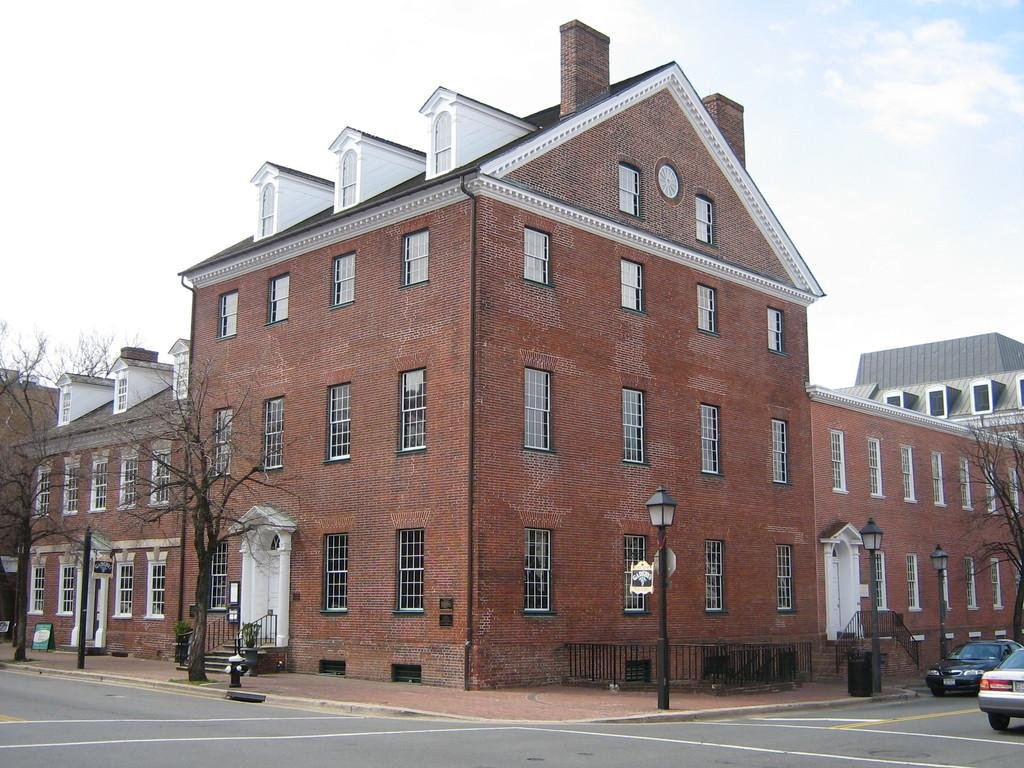What type of structures can be seen in the image? There are buildings in the image. What feature do the buildings have? The buildings have windows. What type of vegetation is present in the image? There are dry trees in the image. What architectural feature can be seen in the image? There are stairs in the image. What safety feature is present in the image? There is railing in the image. What type of street furniture is visible in the image? There are light-poles in the image. What type of transportation is present in the image? There are vehicles on the road in the image. What part of the natural environment is visible in the image? The sky is visible in the image. Can you see any corks floating in the waves in the image? There are no waves or corks present in the image. What type of boot is being worn by the person walking on the dry trees in the image? There are no people or boots visible in the image; it features buildings, dry trees, and other urban elements. 